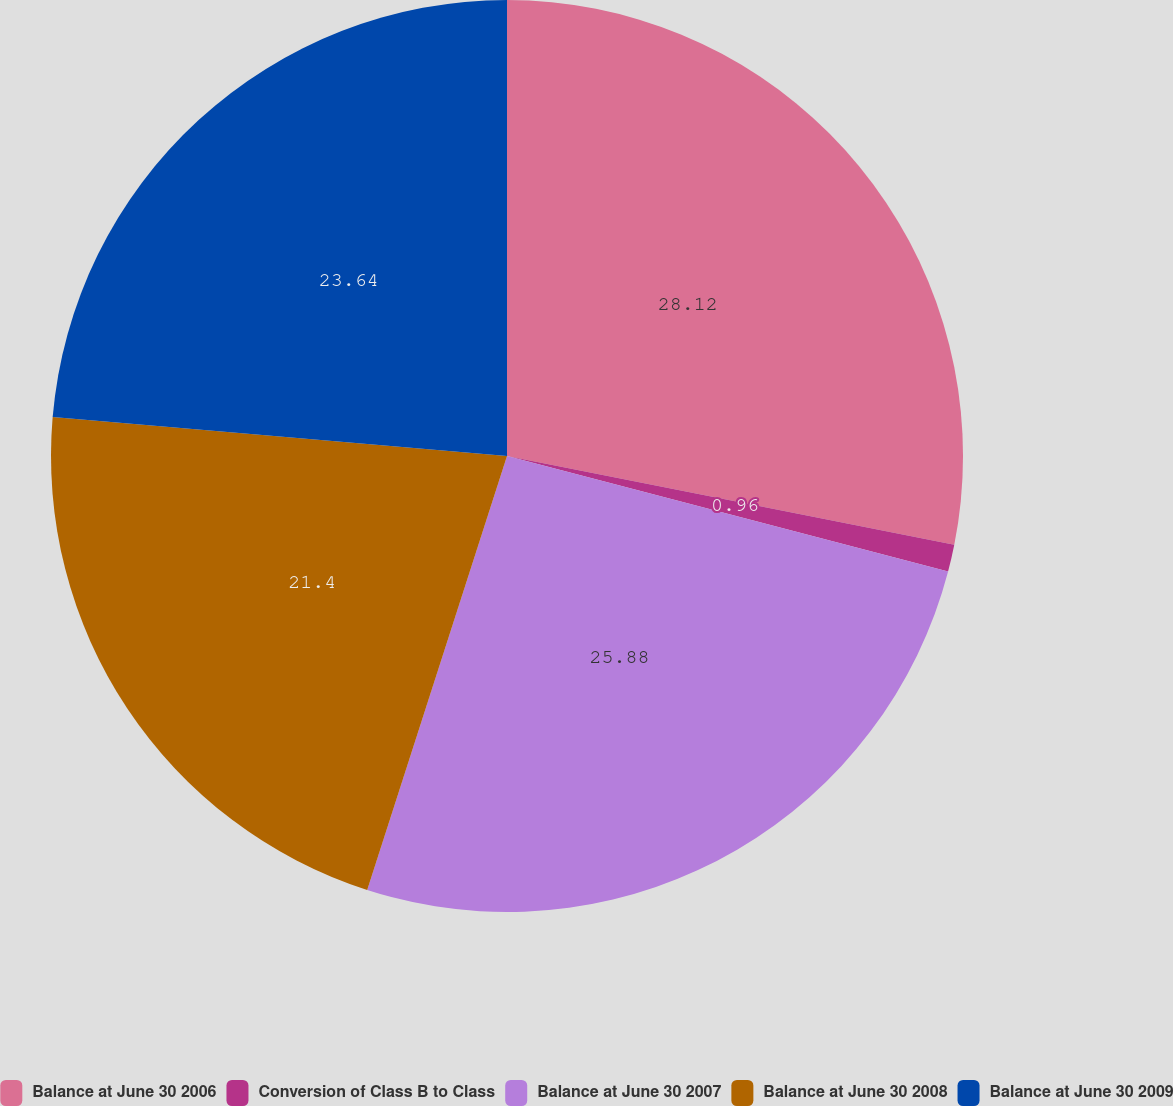<chart> <loc_0><loc_0><loc_500><loc_500><pie_chart><fcel>Balance at June 30 2006<fcel>Conversion of Class B to Class<fcel>Balance at June 30 2007<fcel>Balance at June 30 2008<fcel>Balance at June 30 2009<nl><fcel>28.12%<fcel>0.96%<fcel>25.88%<fcel>21.4%<fcel>23.64%<nl></chart> 